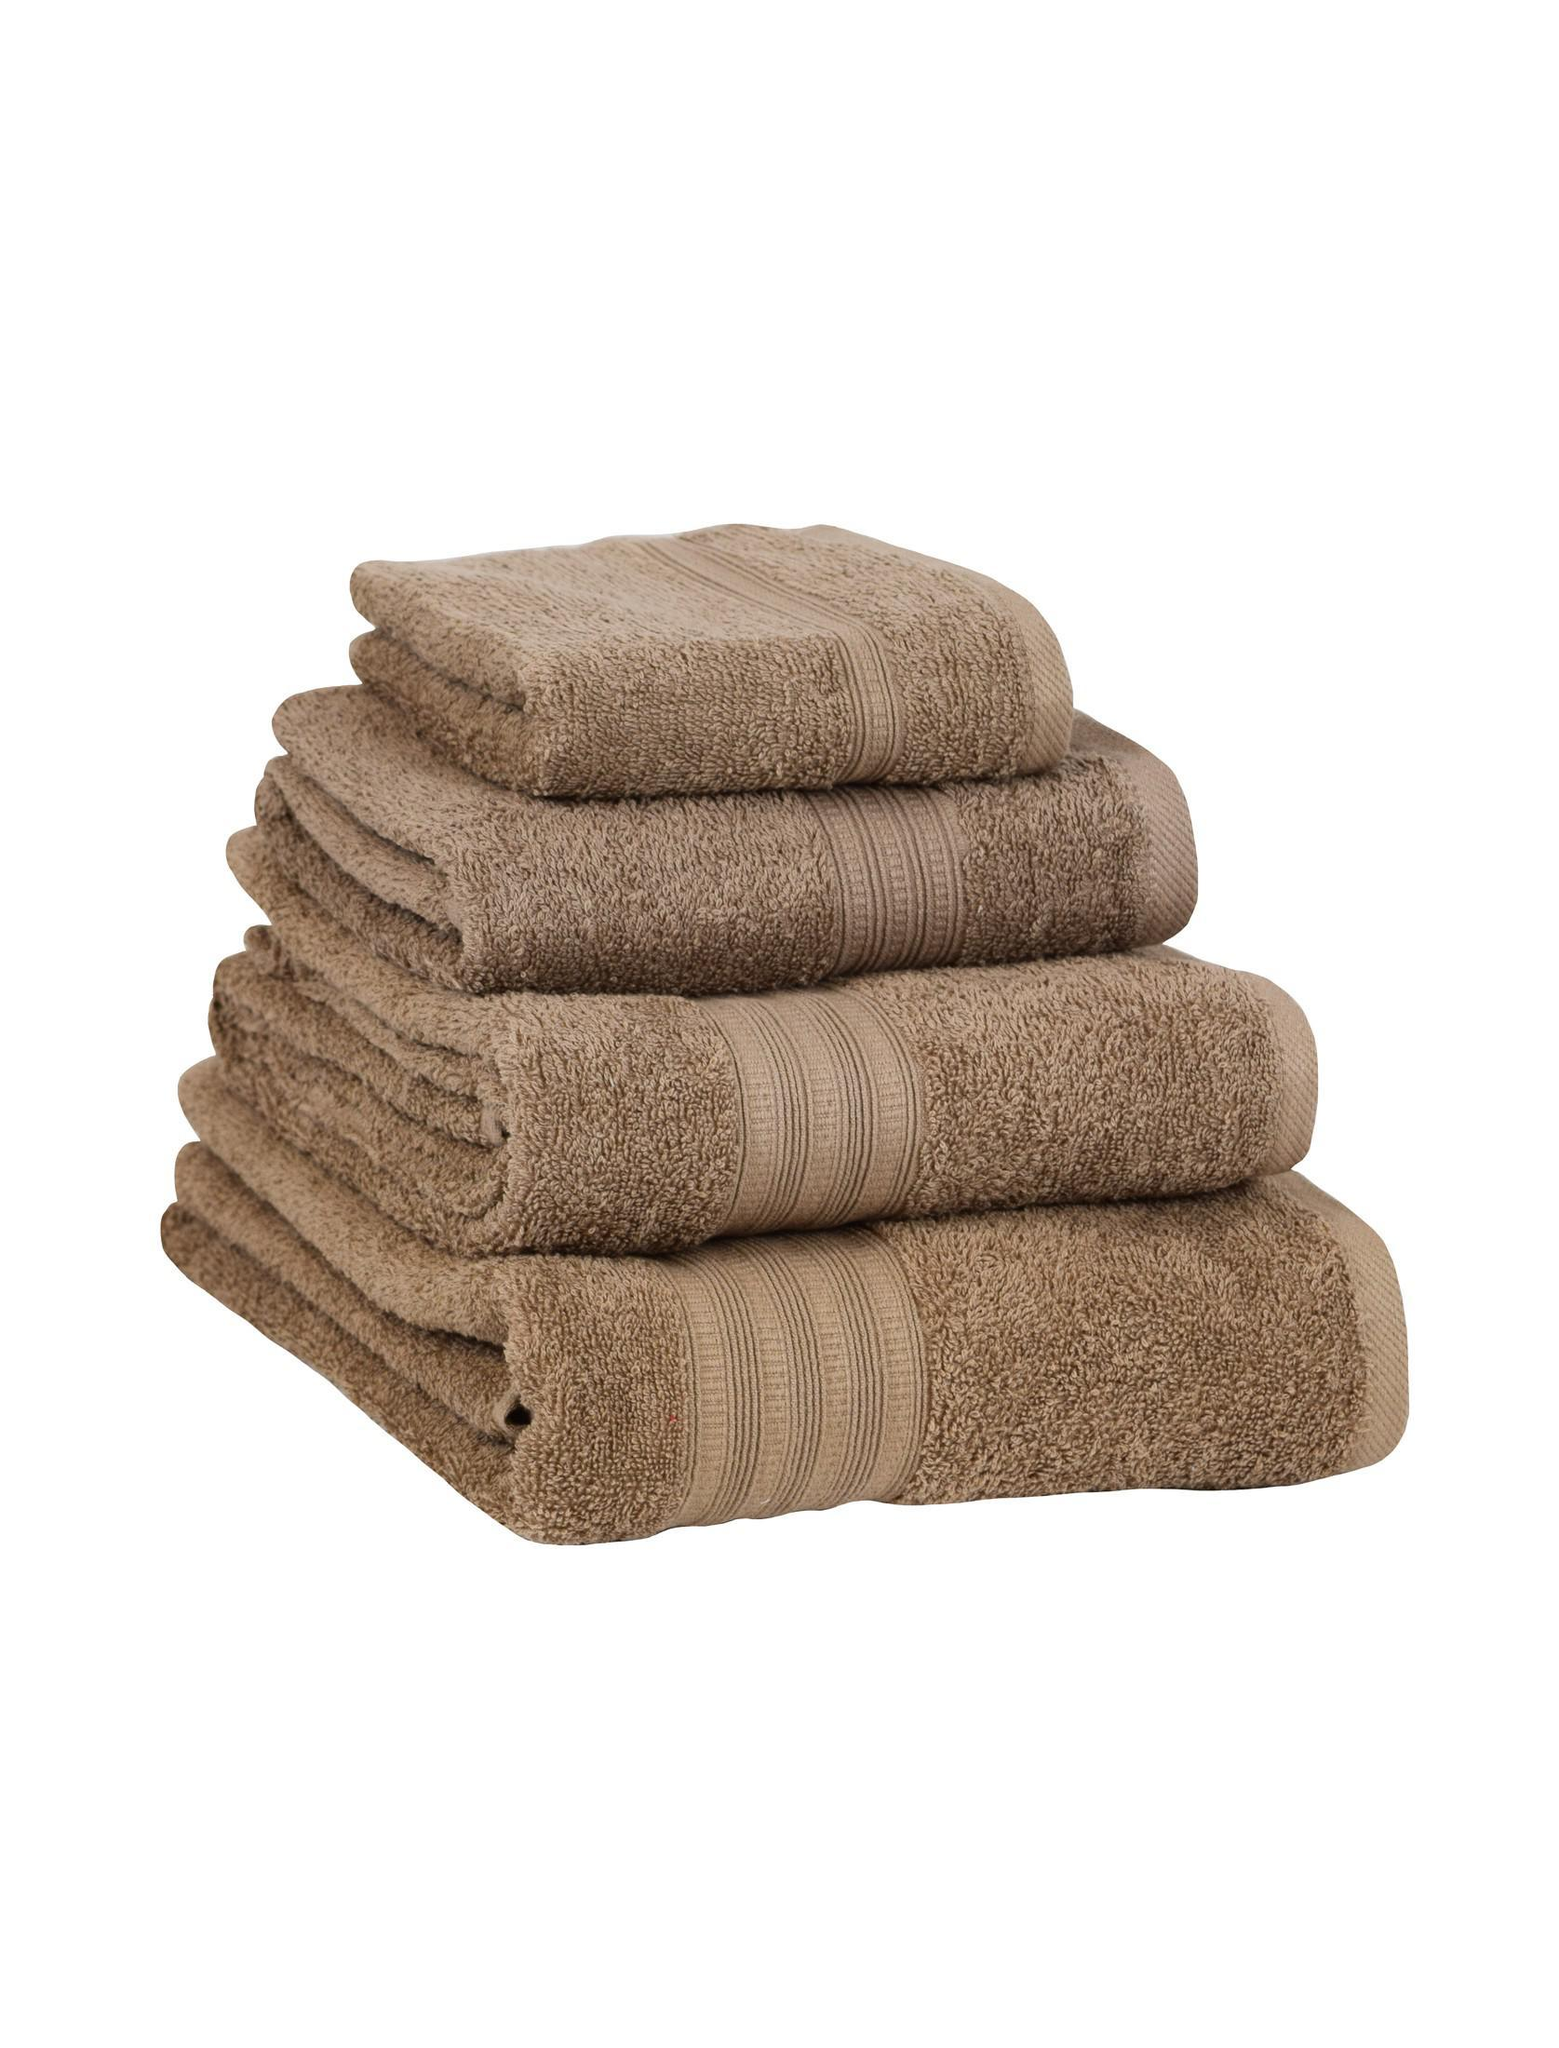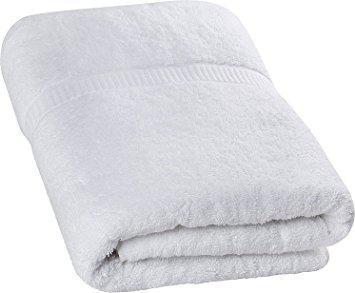The first image is the image on the left, the second image is the image on the right. Evaluate the accuracy of this statement regarding the images: "At least one of the towels is brown.". Is it true? Answer yes or no. Yes. The first image is the image on the left, the second image is the image on the right. Evaluate the accuracy of this statement regarding the images: "There are four towels in the right image.". Is it true? Answer yes or no. No. 